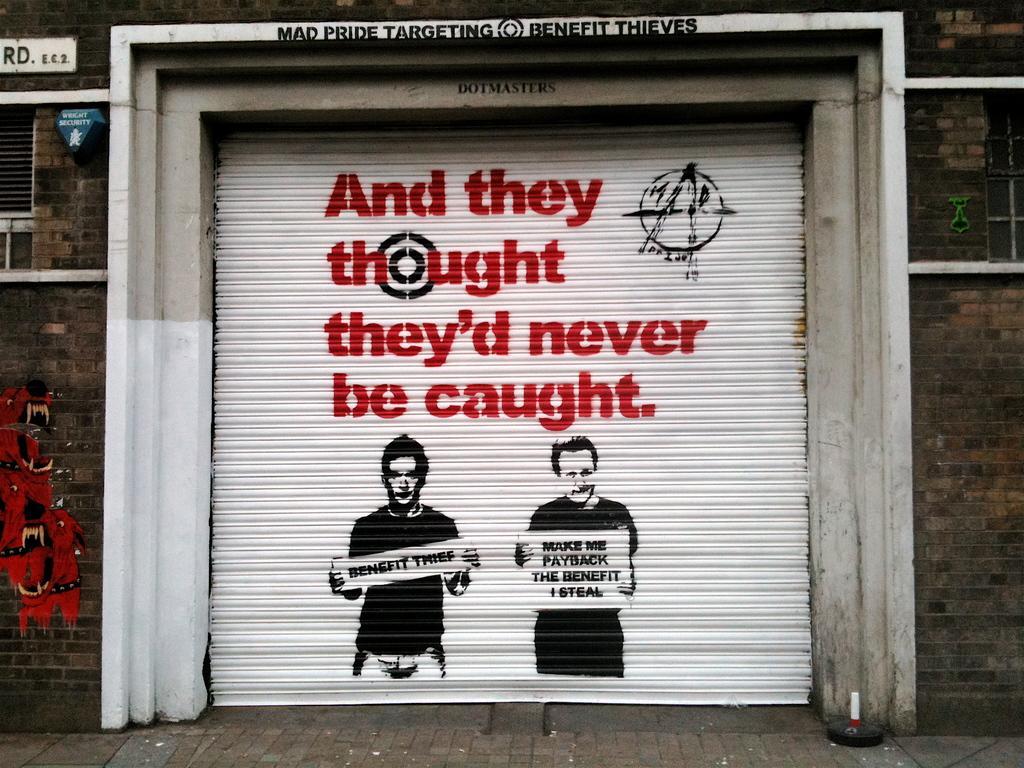How would you summarize this image in a sentence or two? In this image I can see the rolling shutter. On the shutter I can see something is written and the painting of two people. And I can see the board to the wall. 